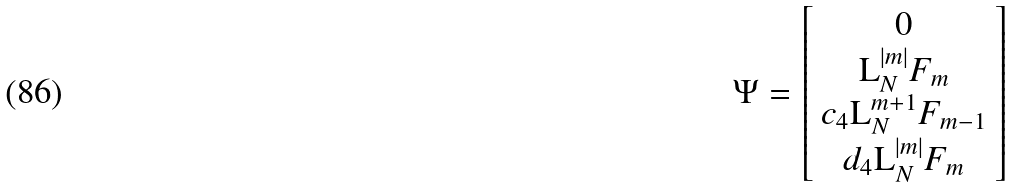<formula> <loc_0><loc_0><loc_500><loc_500>\Psi = \left [ \begin{array} { c } 0 \\ \text {L} _ { N } ^ { \left | m \right | } F _ { m } \\ c _ { 4 } \text {L} _ { N } ^ { m + 1 } F _ { m - 1 } \\ d _ { 4 } \text {L} _ { N } ^ { \left | m \right | } F _ { m } \end{array} \right ]</formula> 